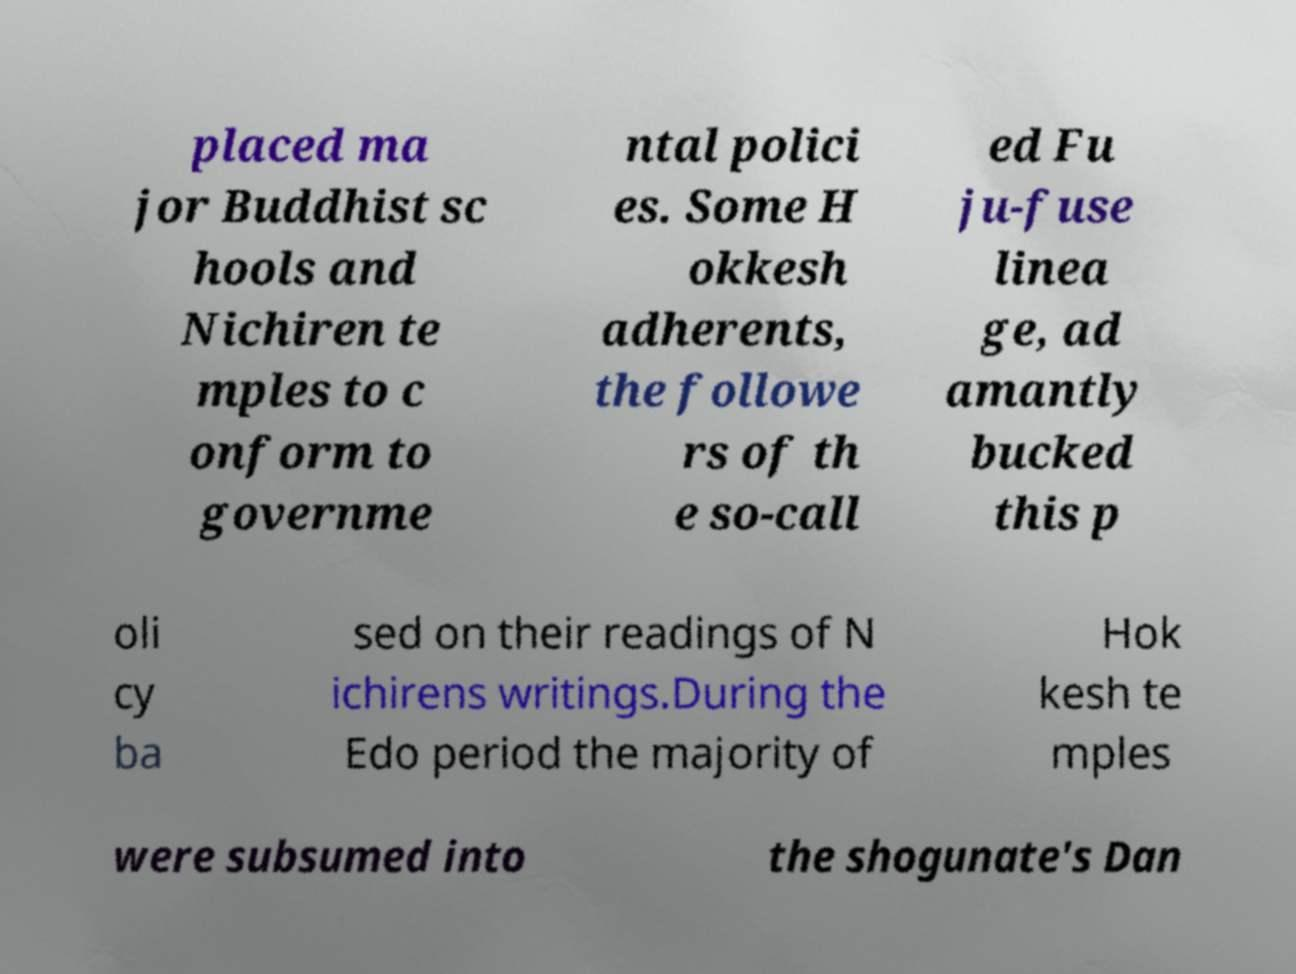Please identify and transcribe the text found in this image. placed ma jor Buddhist sc hools and Nichiren te mples to c onform to governme ntal polici es. Some H okkesh adherents, the followe rs of th e so-call ed Fu ju-fuse linea ge, ad amantly bucked this p oli cy ba sed on their readings of N ichirens writings.During the Edo period the majority of Hok kesh te mples were subsumed into the shogunate's Dan 